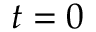<formula> <loc_0><loc_0><loc_500><loc_500>t = 0</formula> 